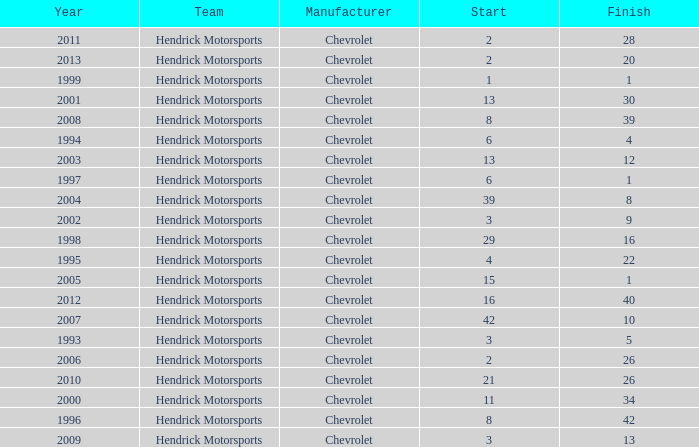I'm looking to parse the entire table for insights. Could you assist me with that? {'header': ['Year', 'Team', 'Manufacturer', 'Start', 'Finish'], 'rows': [['2011', 'Hendrick Motorsports', 'Chevrolet', '2', '28'], ['2013', 'Hendrick Motorsports', 'Chevrolet', '2', '20'], ['1999', 'Hendrick Motorsports', 'Chevrolet', '1', '1'], ['2001', 'Hendrick Motorsports', 'Chevrolet', '13', '30'], ['2008', 'Hendrick Motorsports', 'Chevrolet', '8', '39'], ['1994', 'Hendrick Motorsports', 'Chevrolet', '6', '4'], ['2003', 'Hendrick Motorsports', 'Chevrolet', '13', '12'], ['1997', 'Hendrick Motorsports', 'Chevrolet', '6', '1'], ['2004', 'Hendrick Motorsports', 'Chevrolet', '39', '8'], ['2002', 'Hendrick Motorsports', 'Chevrolet', '3', '9'], ['1998', 'Hendrick Motorsports', 'Chevrolet', '29', '16'], ['1995', 'Hendrick Motorsports', 'Chevrolet', '4', '22'], ['2005', 'Hendrick Motorsports', 'Chevrolet', '15', '1'], ['2012', 'Hendrick Motorsports', 'Chevrolet', '16', '40'], ['2007', 'Hendrick Motorsports', 'Chevrolet', '42', '10'], ['1993', 'Hendrick Motorsports', 'Chevrolet', '3', '5'], ['2006', 'Hendrick Motorsports', 'Chevrolet', '2', '26'], ['2010', 'Hendrick Motorsports', 'Chevrolet', '21', '26'], ['2000', 'Hendrick Motorsports', 'Chevrolet', '11', '34'], ['1996', 'Hendrick Motorsports', 'Chevrolet', '8', '42'], ['2009', 'Hendrick Motorsports', 'Chevrolet', '3', '13']]} What was Jeff's finish in 2011? 28.0. 